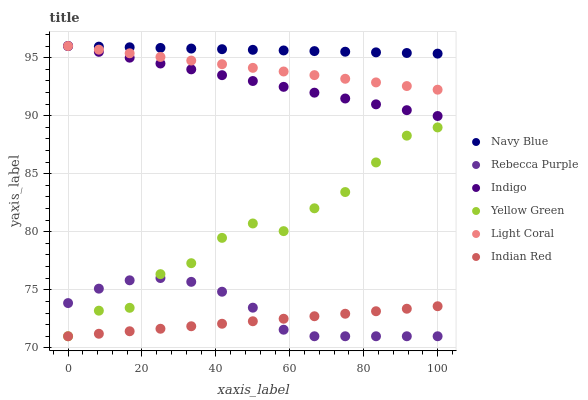Does Indian Red have the minimum area under the curve?
Answer yes or no. Yes. Does Navy Blue have the maximum area under the curve?
Answer yes or no. Yes. Does Yellow Green have the minimum area under the curve?
Answer yes or no. No. Does Yellow Green have the maximum area under the curve?
Answer yes or no. No. Is Indigo the smoothest?
Answer yes or no. Yes. Is Yellow Green the roughest?
Answer yes or no. Yes. Is Navy Blue the smoothest?
Answer yes or no. No. Is Navy Blue the roughest?
Answer yes or no. No. Does Yellow Green have the lowest value?
Answer yes or no. Yes. Does Navy Blue have the lowest value?
Answer yes or no. No. Does Light Coral have the highest value?
Answer yes or no. Yes. Does Yellow Green have the highest value?
Answer yes or no. No. Is Rebecca Purple less than Light Coral?
Answer yes or no. Yes. Is Indigo greater than Rebecca Purple?
Answer yes or no. Yes. Does Rebecca Purple intersect Indian Red?
Answer yes or no. Yes. Is Rebecca Purple less than Indian Red?
Answer yes or no. No. Is Rebecca Purple greater than Indian Red?
Answer yes or no. No. Does Rebecca Purple intersect Light Coral?
Answer yes or no. No. 